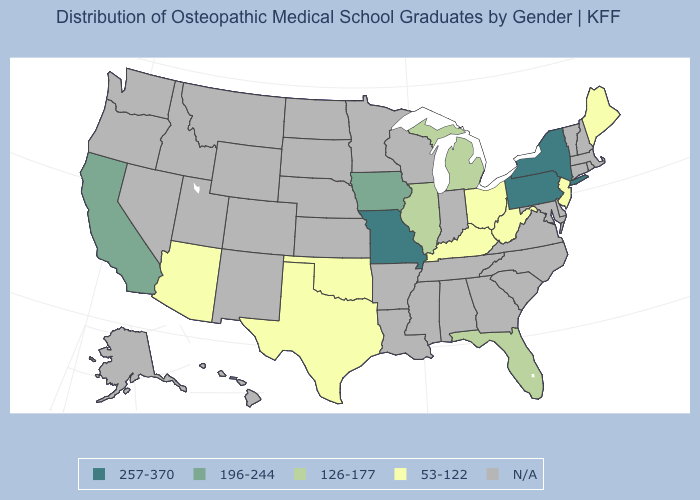What is the value of New Hampshire?
Give a very brief answer. N/A. Which states have the highest value in the USA?
Concise answer only. Missouri, New York, Pennsylvania. What is the value of South Dakota?
Write a very short answer. N/A. Does the map have missing data?
Concise answer only. Yes. Name the states that have a value in the range 126-177?
Short answer required. Florida, Illinois, Michigan. Name the states that have a value in the range 257-370?
Write a very short answer. Missouri, New York, Pennsylvania. Is the legend a continuous bar?
Give a very brief answer. No. Is the legend a continuous bar?
Write a very short answer. No. What is the value of South Dakota?
Concise answer only. N/A. Among the states that border Indiana , which have the highest value?
Give a very brief answer. Illinois, Michigan. What is the highest value in states that border Alabama?
Keep it brief. 126-177. Name the states that have a value in the range 257-370?
Give a very brief answer. Missouri, New York, Pennsylvania. Name the states that have a value in the range 257-370?
Quick response, please. Missouri, New York, Pennsylvania. What is the highest value in states that border Illinois?
Keep it brief. 257-370. Is the legend a continuous bar?
Give a very brief answer. No. 